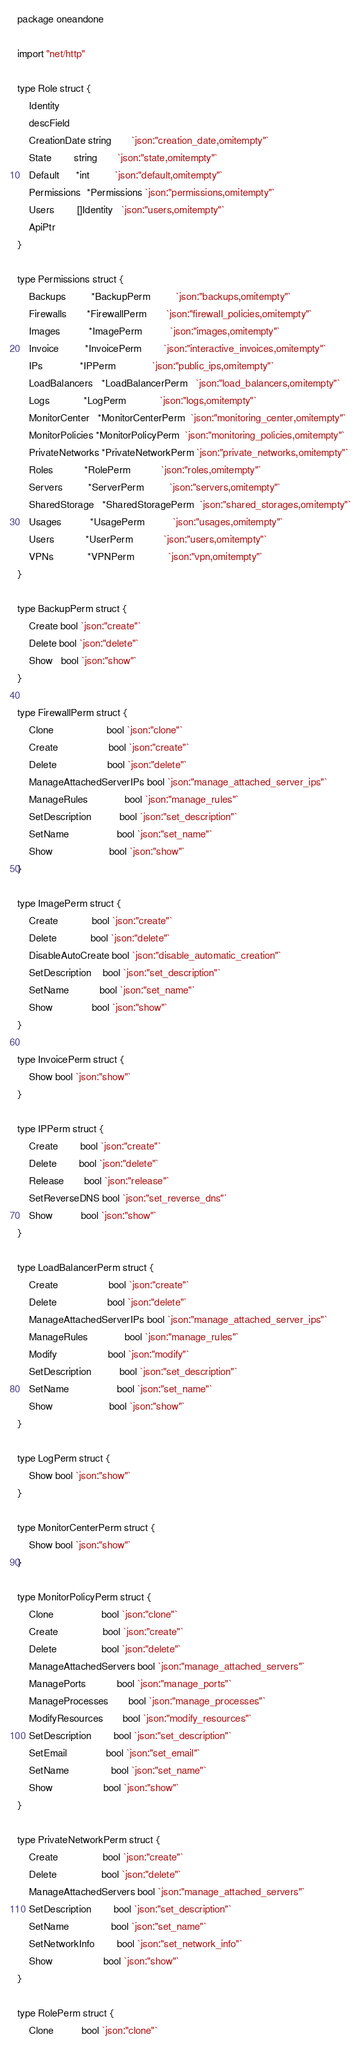<code> <loc_0><loc_0><loc_500><loc_500><_Go_>package oneandone

import "net/http"

type Role struct {
	Identity
	descField
	CreationDate string       `json:"creation_date,omitempty"`
	State        string       `json:"state,omitempty"`
	Default      *int         `json:"default,omitempty"`
	Permissions  *Permissions `json:"permissions,omitempty"`
	Users        []Identity   `json:"users,omitempty"`
	ApiPtr
}

type Permissions struct {
	Backups         *BackupPerm         `json:"backups,omitempty"`
	Firewalls       *FirewallPerm       `json:"firewall_policies,omitempty"`
	Images          *ImagePerm          `json:"images,omitempty"`
	Invoice         *InvoicePerm        `json:"interactive_invoices,omitempty"`
	IPs             *IPPerm             `json:"public_ips,omitempty"`
	LoadBalancers   *LoadBalancerPerm   `json:"load_balancers,omitempty"`
	Logs            *LogPerm            `json:"logs,omitempty"`
	MonitorCenter   *MonitorCenterPerm  `json:"monitoring_center,omitempty"`
	MonitorPolicies *MonitorPolicyPerm  `json:"monitoring_policies,omitempty"`
	PrivateNetworks *PrivateNetworkPerm `json:"private_networks,omitempty"`
	Roles           *RolePerm           `json:"roles,omitempty"`
	Servers         *ServerPerm         `json:"servers,omitempty"`
	SharedStorage   *SharedStoragePerm  `json:"shared_storages,omitempty"`
	Usages          *UsagePerm          `json:"usages,omitempty"`
	Users           *UserPerm           `json:"users,omitempty"`
	VPNs            *VPNPerm            `json:"vpn,omitempty"`
}

type BackupPerm struct {
	Create bool `json:"create"`
	Delete bool `json:"delete"`
	Show   bool `json:"show"`
}

type FirewallPerm struct {
	Clone                   bool `json:"clone"`
	Create                  bool `json:"create"`
	Delete                  bool `json:"delete"`
	ManageAttachedServerIPs bool `json:"manage_attached_server_ips"`
	ManageRules             bool `json:"manage_rules"`
	SetDescription          bool `json:"set_description"`
	SetName                 bool `json:"set_name"`
	Show                    bool `json:"show"`
}

type ImagePerm struct {
	Create            bool `json:"create"`
	Delete            bool `json:"delete"`
	DisableAutoCreate bool `json:"disable_automatic_creation"`
	SetDescription    bool `json:"set_description"`
	SetName           bool `json:"set_name"`
	Show              bool `json:"show"`
}

type InvoicePerm struct {
	Show bool `json:"show"`
}

type IPPerm struct {
	Create        bool `json:"create"`
	Delete        bool `json:"delete"`
	Release       bool `json:"release"`
	SetReverseDNS bool `json:"set_reverse_dns"`
	Show          bool `json:"show"`
}

type LoadBalancerPerm struct {
	Create                  bool `json:"create"`
	Delete                  bool `json:"delete"`
	ManageAttachedServerIPs bool `json:"manage_attached_server_ips"`
	ManageRules             bool `json:"manage_rules"`
	Modify                  bool `json:"modify"`
	SetDescription          bool `json:"set_description"`
	SetName                 bool `json:"set_name"`
	Show                    bool `json:"show"`
}

type LogPerm struct {
	Show bool `json:"show"`
}

type MonitorCenterPerm struct {
	Show bool `json:"show"`
}

type MonitorPolicyPerm struct {
	Clone                 bool `json:"clone"`
	Create                bool `json:"create"`
	Delete                bool `json:"delete"`
	ManageAttachedServers bool `json:"manage_attached_servers"`
	ManagePorts           bool `json:"manage_ports"`
	ManageProcesses       bool `json:"manage_processes"`
	ModifyResources       bool `json:"modify_resources"`
	SetDescription        bool `json:"set_description"`
	SetEmail              bool `json:"set_email"`
	SetName               bool `json:"set_name"`
	Show                  bool `json:"show"`
}

type PrivateNetworkPerm struct {
	Create                bool `json:"create"`
	Delete                bool `json:"delete"`
	ManageAttachedServers bool `json:"manage_attached_servers"`
	SetDescription        bool `json:"set_description"`
	SetName               bool `json:"set_name"`
	SetNetworkInfo        bool `json:"set_network_info"`
	Show                  bool `json:"show"`
}

type RolePerm struct {
	Clone          bool `json:"clone"`</code> 